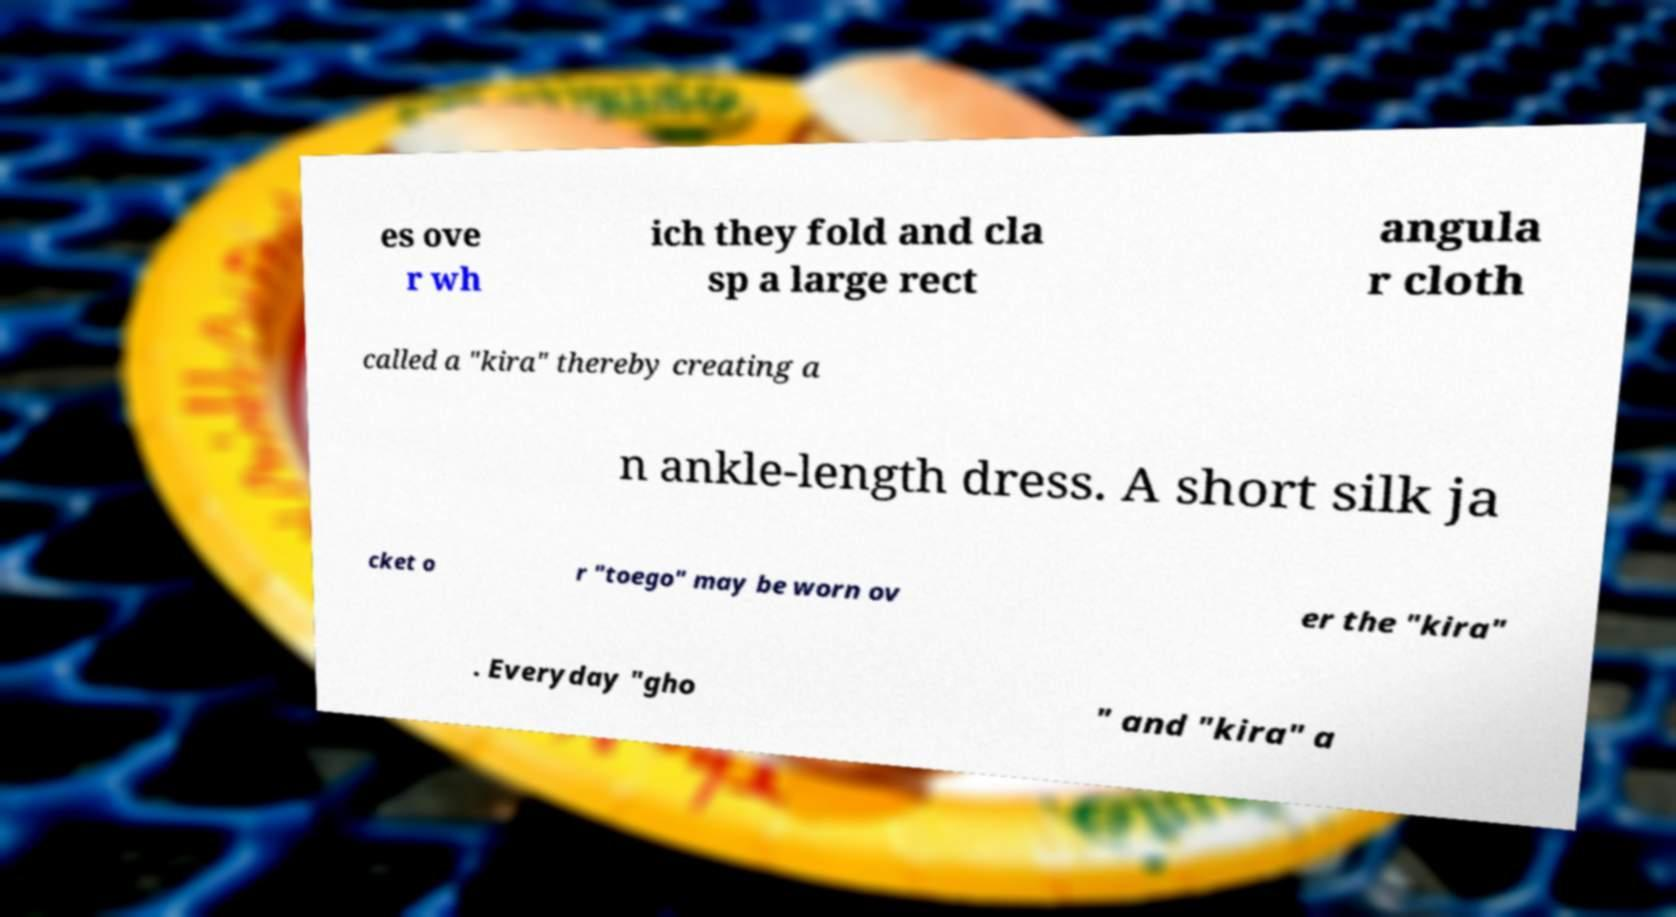There's text embedded in this image that I need extracted. Can you transcribe it verbatim? es ove r wh ich they fold and cla sp a large rect angula r cloth called a "kira" thereby creating a n ankle-length dress. A short silk ja cket o r "toego" may be worn ov er the "kira" . Everyday "gho " and "kira" a 